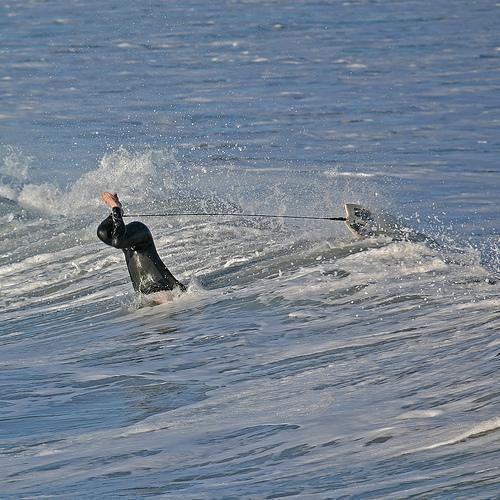How many surfers?
Give a very brief answer. 1. 